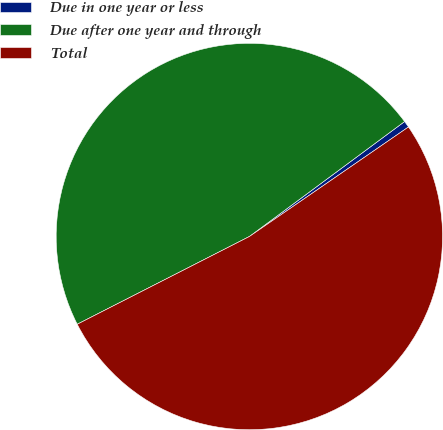Convert chart to OTSL. <chart><loc_0><loc_0><loc_500><loc_500><pie_chart><fcel>Due in one year or less<fcel>Due after one year and through<fcel>Total<nl><fcel>0.55%<fcel>47.36%<fcel>52.1%<nl></chart> 